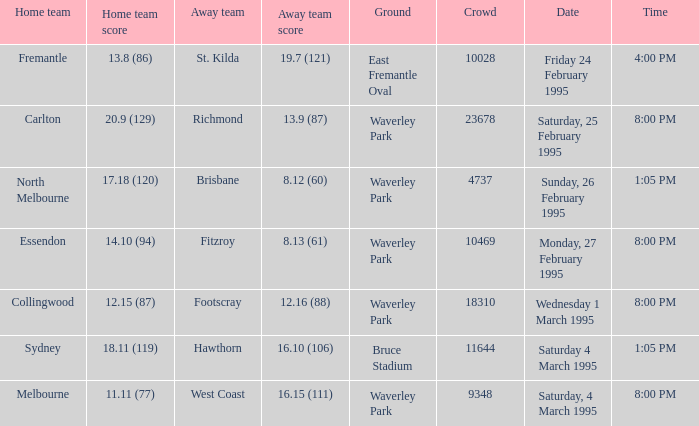Name the time for saturday 4 march 1995 1:05 PM. 